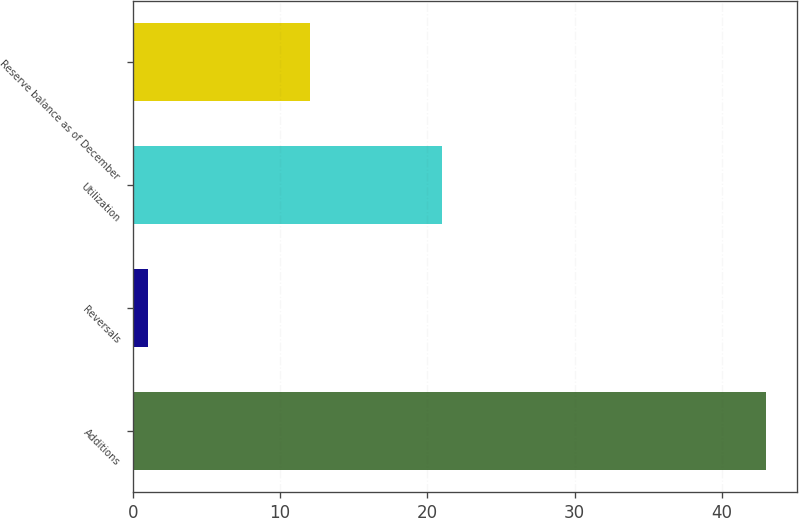Convert chart to OTSL. <chart><loc_0><loc_0><loc_500><loc_500><bar_chart><fcel>Additions<fcel>Reversals<fcel>Utilization<fcel>Reserve balance as of December<nl><fcel>43<fcel>1<fcel>21<fcel>12<nl></chart> 